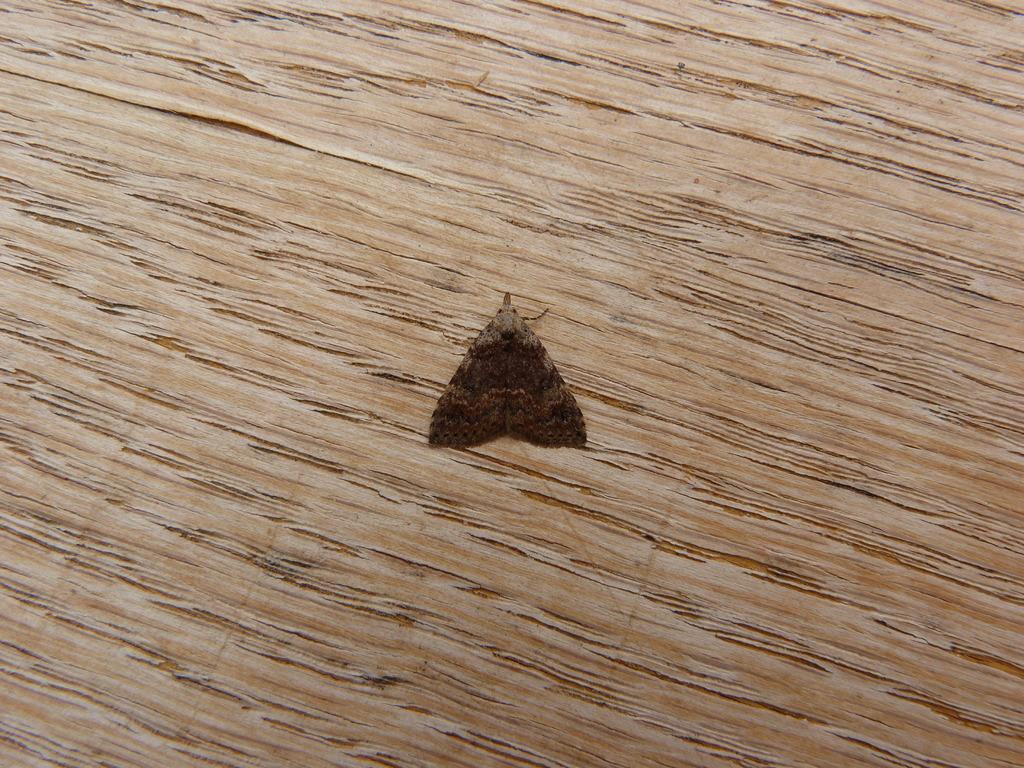Can you describe this image briefly? In this picture there is an insect. At the bottom there is a wooden floor. 